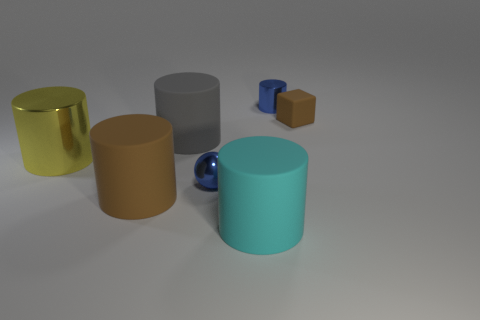What number of other things are there of the same shape as the tiny matte object?
Offer a very short reply. 0. There is a shiny cylinder to the left of the big cyan matte object; what color is it?
Make the answer very short. Yellow. What number of gray rubber cylinders are in front of the tiny shiny thing left of the shiny thing that is behind the big yellow object?
Offer a terse response. 0. There is a large object that is behind the yellow cylinder; how many blue things are to the left of it?
Make the answer very short. 0. How many tiny metal cylinders are in front of the metallic sphere?
Keep it short and to the point. 0. How many other objects are there of the same size as the cyan rubber cylinder?
Provide a succinct answer. 3. What is the size of the blue metallic object that is the same shape as the gray rubber object?
Make the answer very short. Small. What is the shape of the brown object that is on the right side of the blue metal ball?
Offer a very short reply. Cube. What is the color of the big rubber cylinder that is behind the blue thing that is in front of the tiny cube?
Offer a very short reply. Gray. What number of things are either objects in front of the big yellow metallic cylinder or red cylinders?
Offer a terse response. 3. 